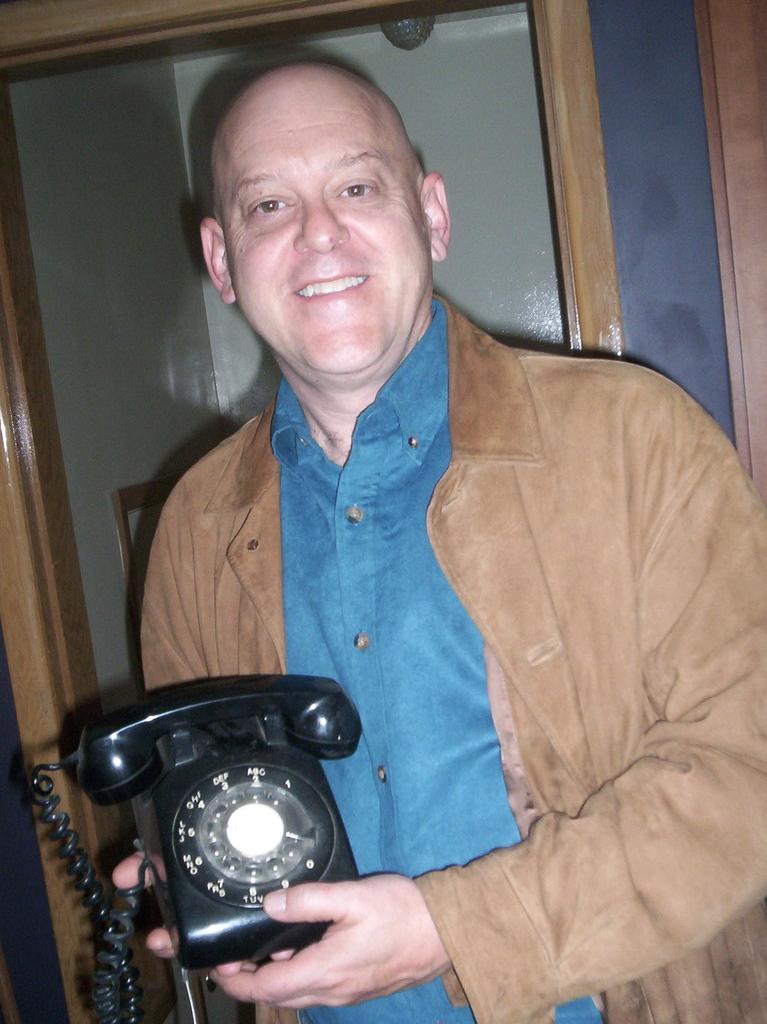Describe this image in one or two sentences. In this image, we can see a man is holding a telephone and watching. He is smiling. Background we can see the wall, frame and wooden objects. 